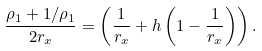Convert formula to latex. <formula><loc_0><loc_0><loc_500><loc_500>\frac { \rho _ { 1 } + 1 / \rho _ { 1 } } { 2 r _ { x } } = \left ( \frac { 1 } { r _ { x } } + h \left ( 1 - \frac { 1 } { r _ { x } } \right ) \right ) .</formula> 